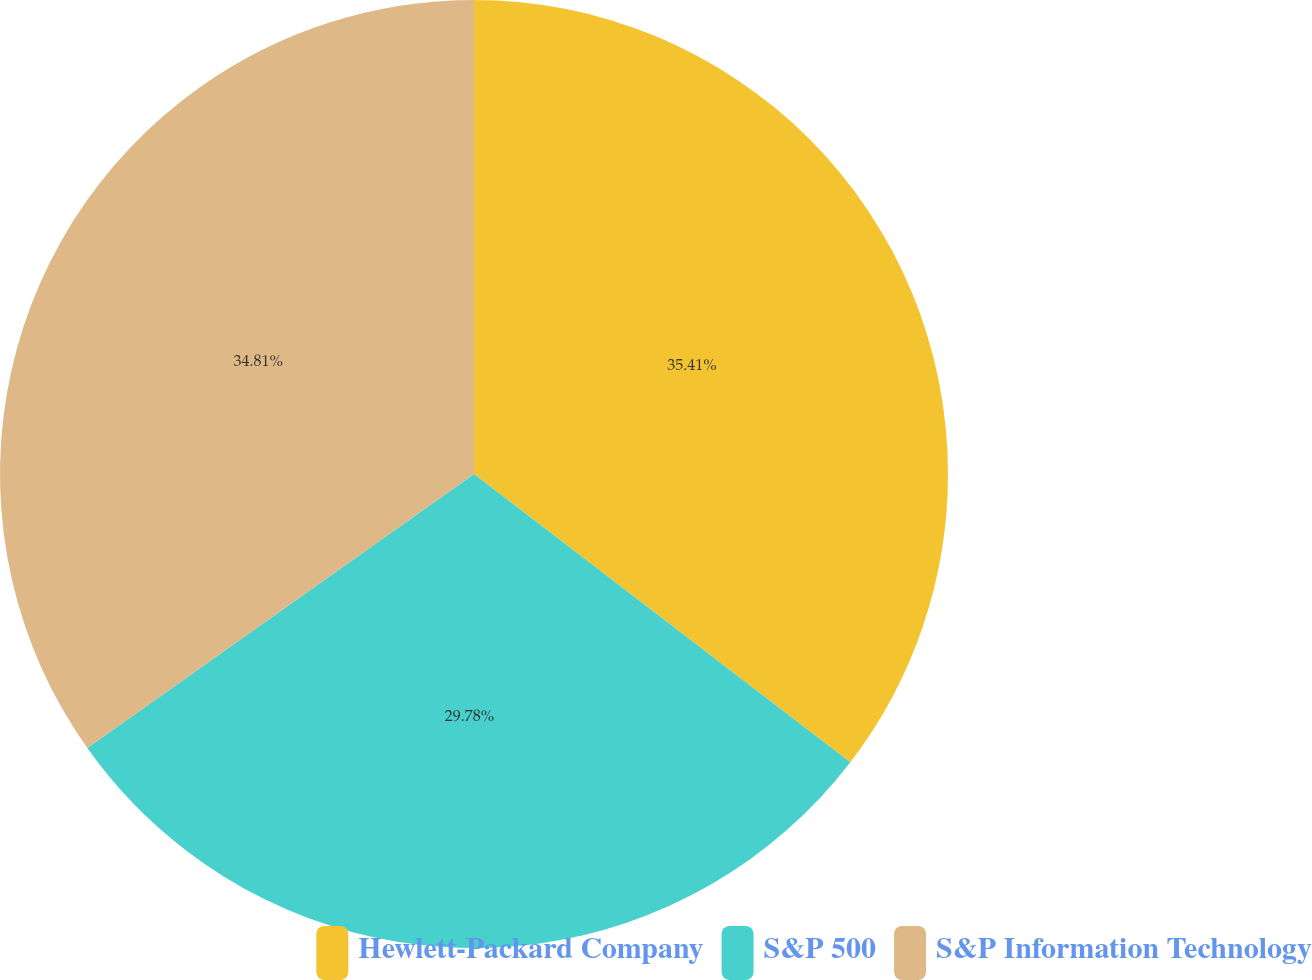<chart> <loc_0><loc_0><loc_500><loc_500><pie_chart><fcel>Hewlett-Packard Company<fcel>S&P 500<fcel>S&P Information Technology<nl><fcel>35.4%<fcel>29.78%<fcel>34.81%<nl></chart> 